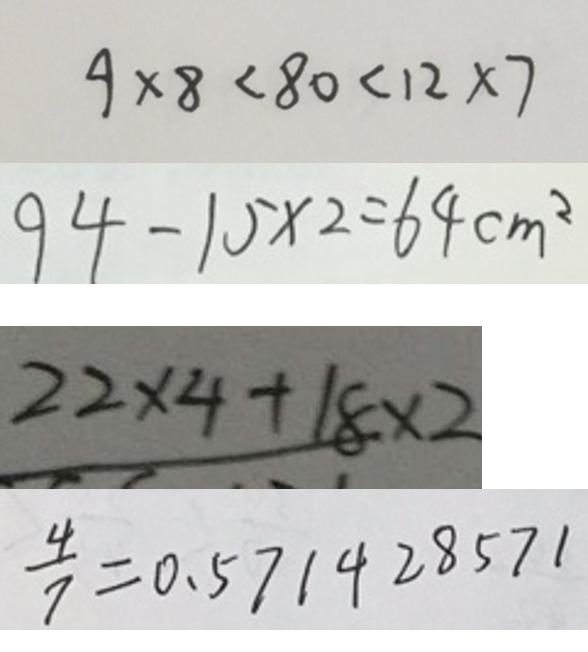<formula> <loc_0><loc_0><loc_500><loc_500>9 \times 8 < 8 0 < 1 2 \times 7 
 9 4 - 1 5 \times 2 = 6 4 c m ^ { 2 } 
 2 2 \times 4 + 1 8 \times 2 
 \frac { 4 } { 7 } = 0 . 5 7 1 4 2 8 5 7 1</formula> 